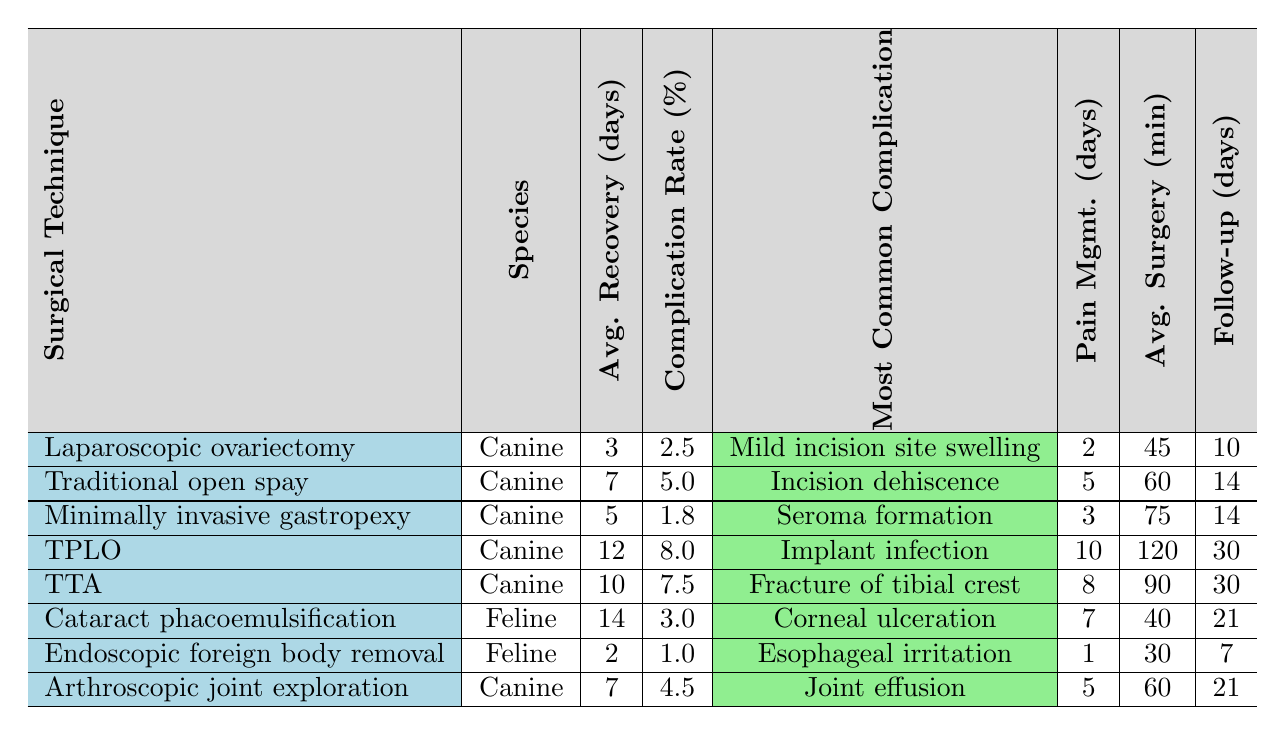What is the average recovery time for a laparoscopic ovariectomy? The table indicates that for laparoscopic ovariectomy, the average recovery time is listed as 3 days.
Answer: 3 days Which surgical technique has the highest complication rate? By examining the complication rate percentages, the TPLO (Tibial Plateau Leveling Osteotomy) has the highest percentage at 8.0%.
Answer: TPLO How many days of pain management are required after a traditional open spay? According to the table, the pain management required after a traditional open spay is 5 days.
Answer: 5 days What is the most common complication associated with minimally invasive gastropexy? The table shows that the most common complication for minimally invasive gastropexy is seroma formation.
Answer: Seroma formation Calculate the average recovery time for all the canine surgical techniques listed. The average recovery time for canine techniques is calculated by adding the recovery times (3+7+5+12+10+2+7) = 46 days. With 7 techniques, the average is 46/7 = 6.57 days (approximately 6.6 days).
Answer: 6.6 days Is the complication rate for endoscopic foreign body removal lower or higher than that of cataract phacoemulsification? The complication rate for endoscopic foreign body removal is 1.0%, while cataract phacoemulsification has a 3.0% rate. Since 1.0% is less than 3.0%, endoscopic foreign body removal has a lower rate.
Answer: Lower Which surgical technique has the longest average surgery duration? The average surgery duration for TPLO is 120 minutes, which is the longest compared to the other techniques listed in the table.
Answer: TPLO What is the follow-up period for the TTA surgical technique? The table indicates that the recommended follow-up period for the TTA is 30 days.
Answer: 30 days How does the complication rate of laparoscopic ovariectomy compare with that of arthroscopic joint exploration? The complication rate for laparoscopic ovariectomy is 2.5%, whereas for arthroscopic joint exploration it is 4.5%. Since 2.5% is lower than 4.5%, laparoscopic ovariectomy has a lower complication rate.
Answer: Lower What is the average recovery time for feline surgical techniques? The average recovery time for feline techniques (14 days for cataract phacoemulsification and 2 days for endoscopic foreign body removal) is (14 + 2) = 16 days. Dividing by 2 gives an average of 8 days.
Answer: 8 days 